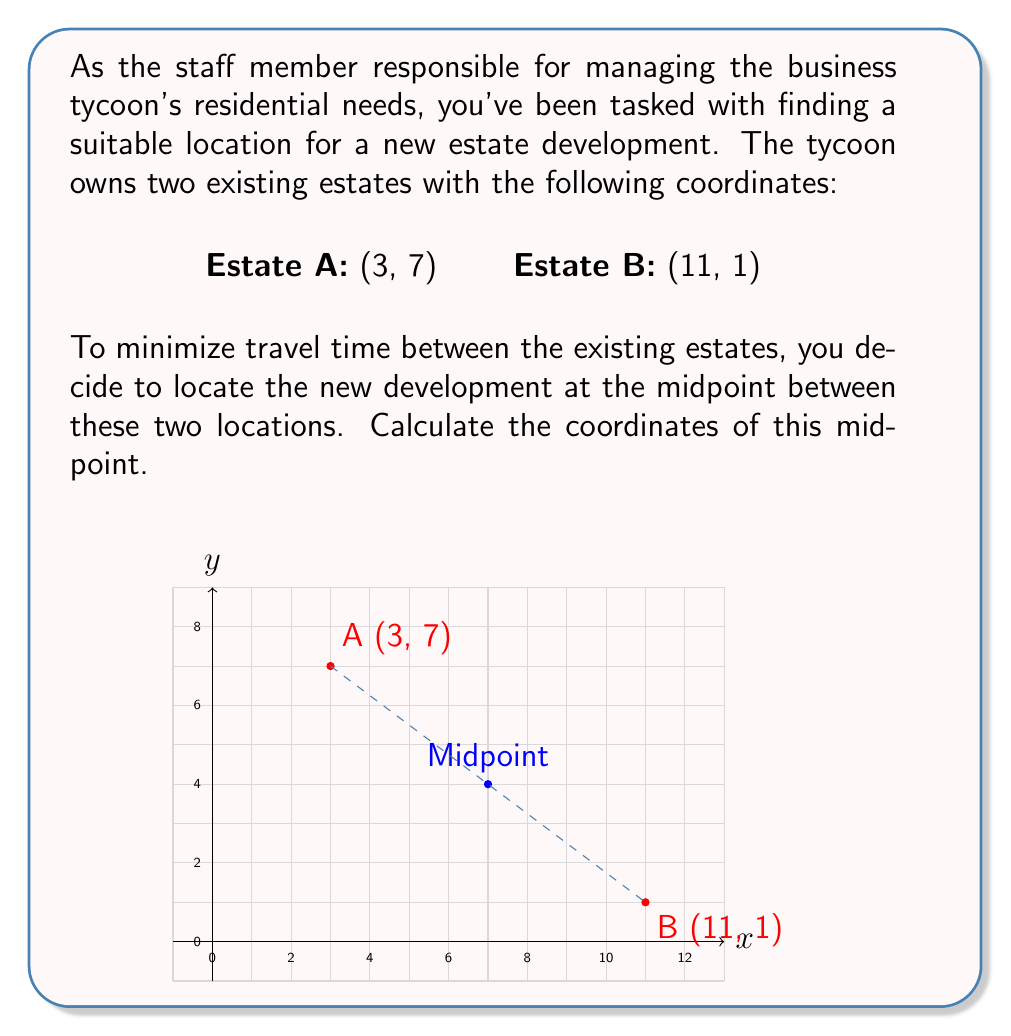Solve this math problem. To find the midpoint between two points, we use the midpoint formula:

$$ \text{Midpoint} = \left(\frac{x_1 + x_2}{2}, \frac{y_1 + y_2}{2}\right) $$

Where $(x_1, y_1)$ are the coordinates of the first point and $(x_2, y_2)$ are the coordinates of the second point.

Let's apply this formula to our estate locations:

1. For the x-coordinate:
   $$ x = \frac{x_1 + x_2}{2} = \frac{3 + 11}{2} = \frac{14}{2} = 7 $$

2. For the y-coordinate:
   $$ y = \frac{y_1 + y_2}{2} = \frac{7 + 1}{2} = \frac{8}{2} = 4 $$

Therefore, the midpoint between Estate A (3, 7) and Estate B (11, 1) is (7, 4).
Answer: (7, 4) 